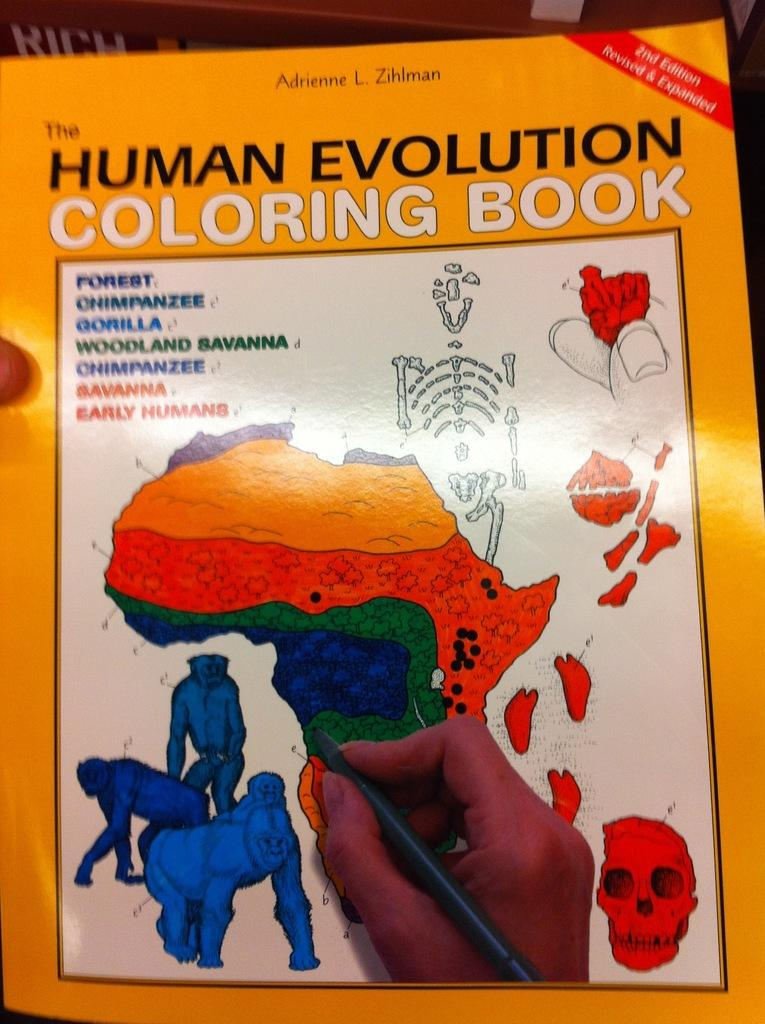What object is present in the image that is commonly used for reading and learning? There is a book in the image. What features does the book have? The book has pictures and text. What can be seen in the image that might be used for writing? There is a hand holding a pen in the image. How many sacks are being used to carry the cars in the image? There are no sacks or cars present in the image; it only features a book with pictures and text, and a hand holding a pen. 